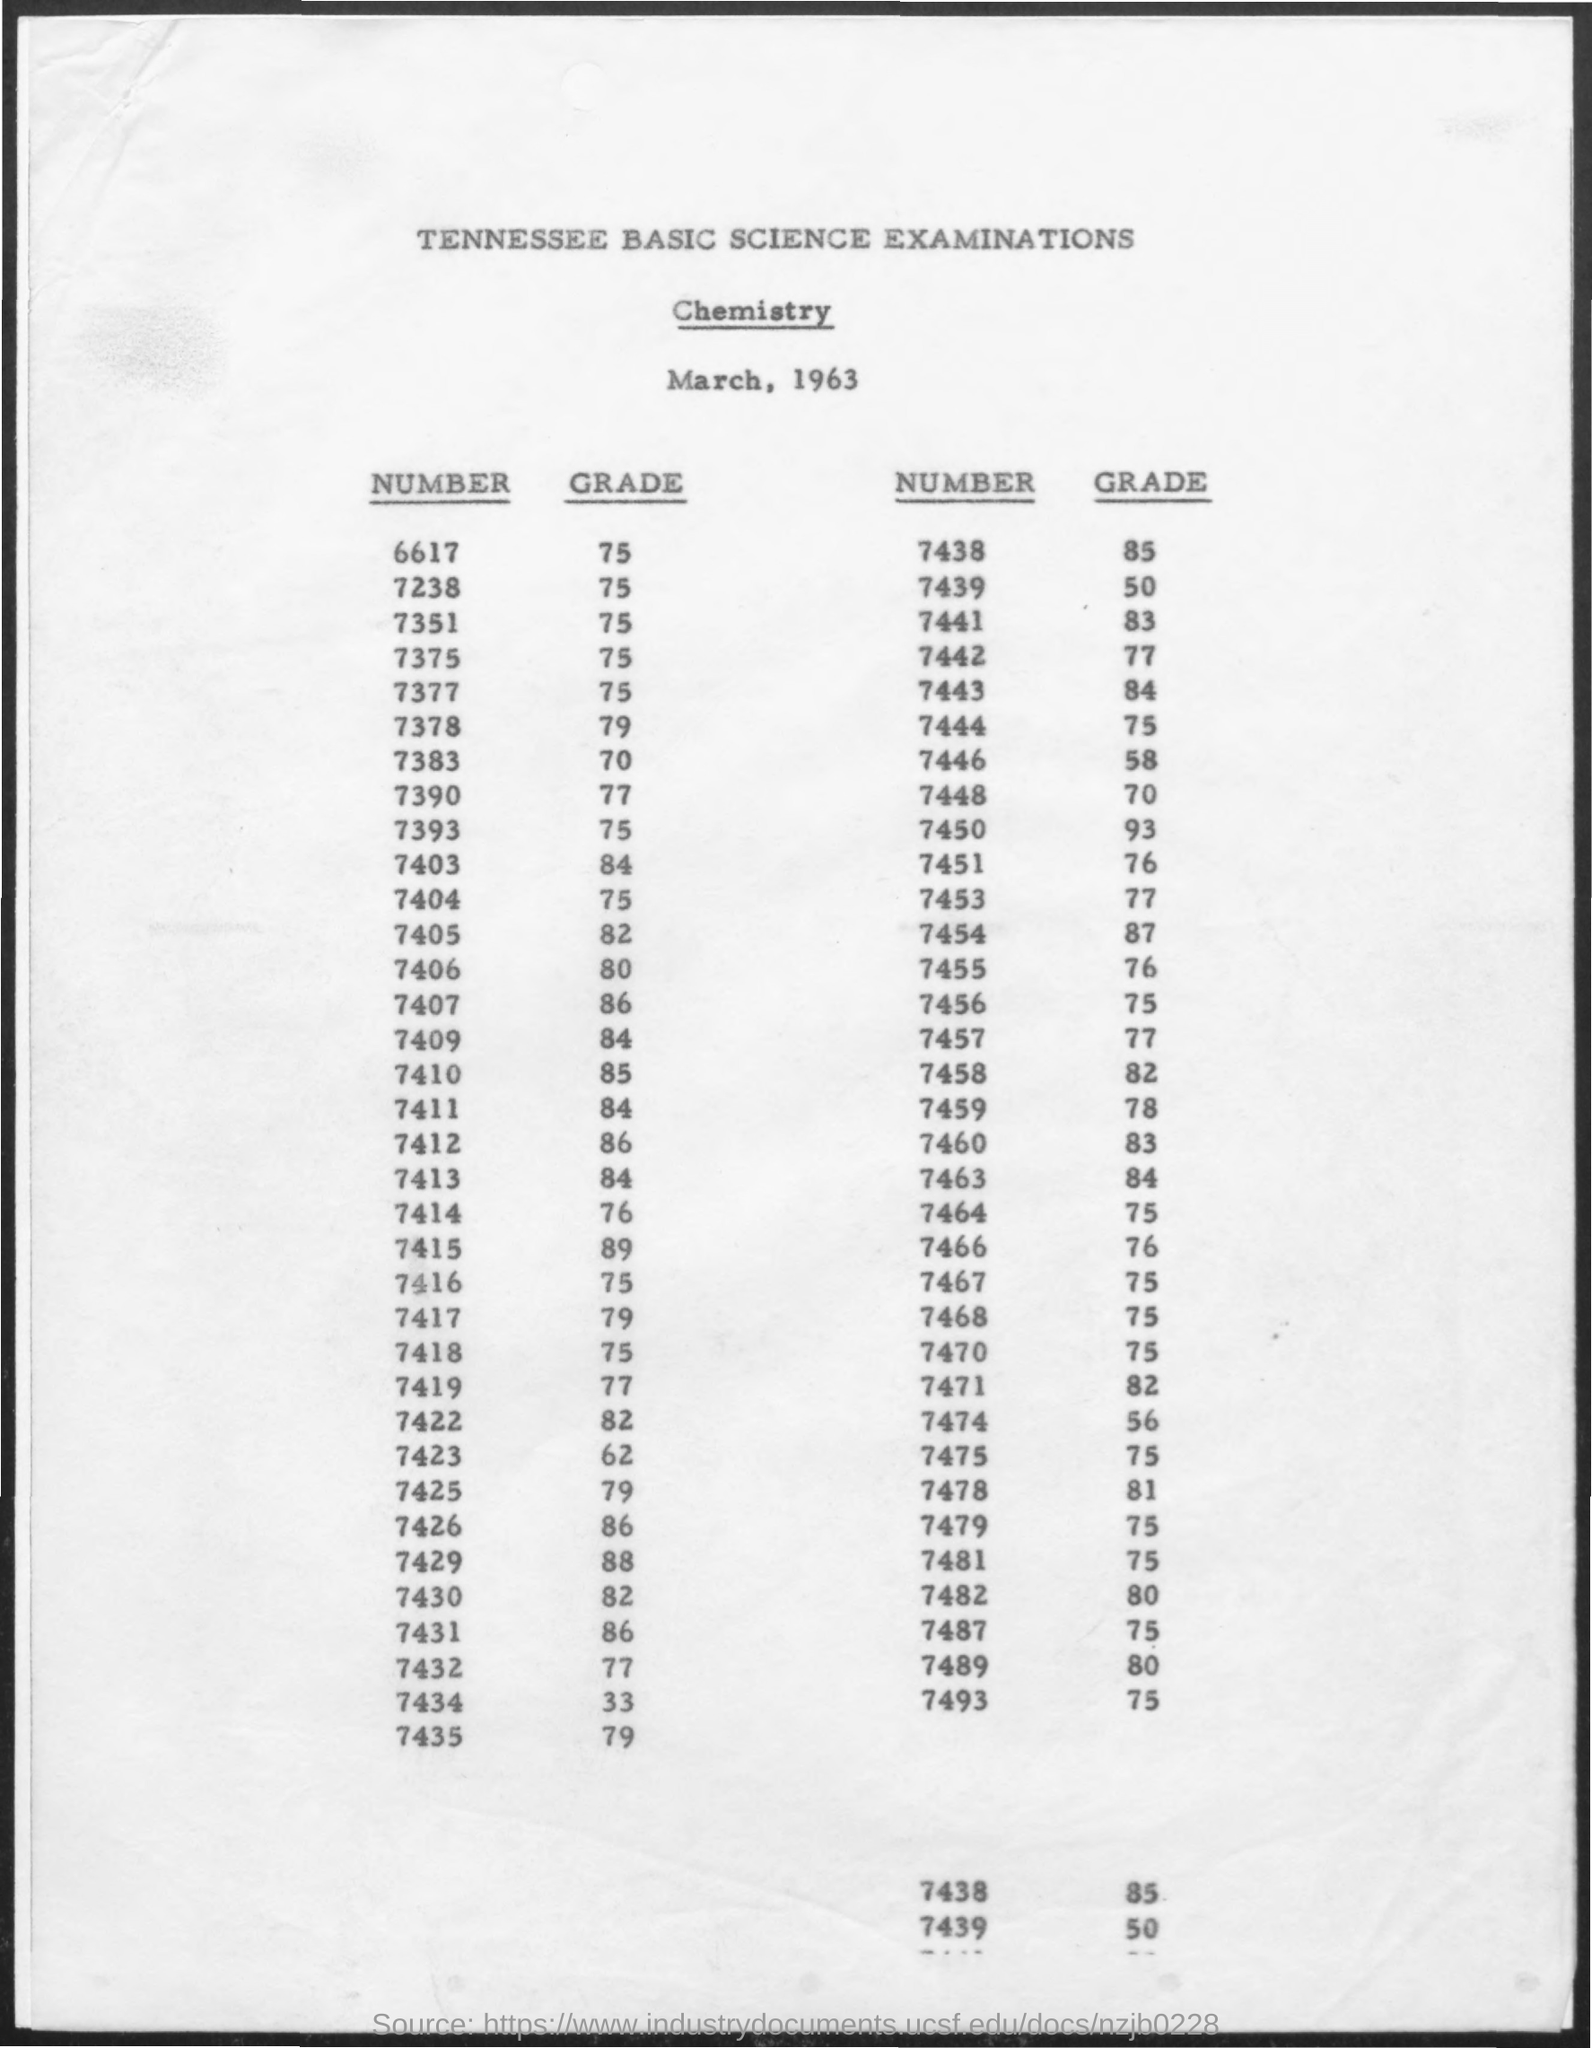What is the lowest grade visible on this document? The lowest grade listed on this document is 50, for numbers 7439 and 7448. 